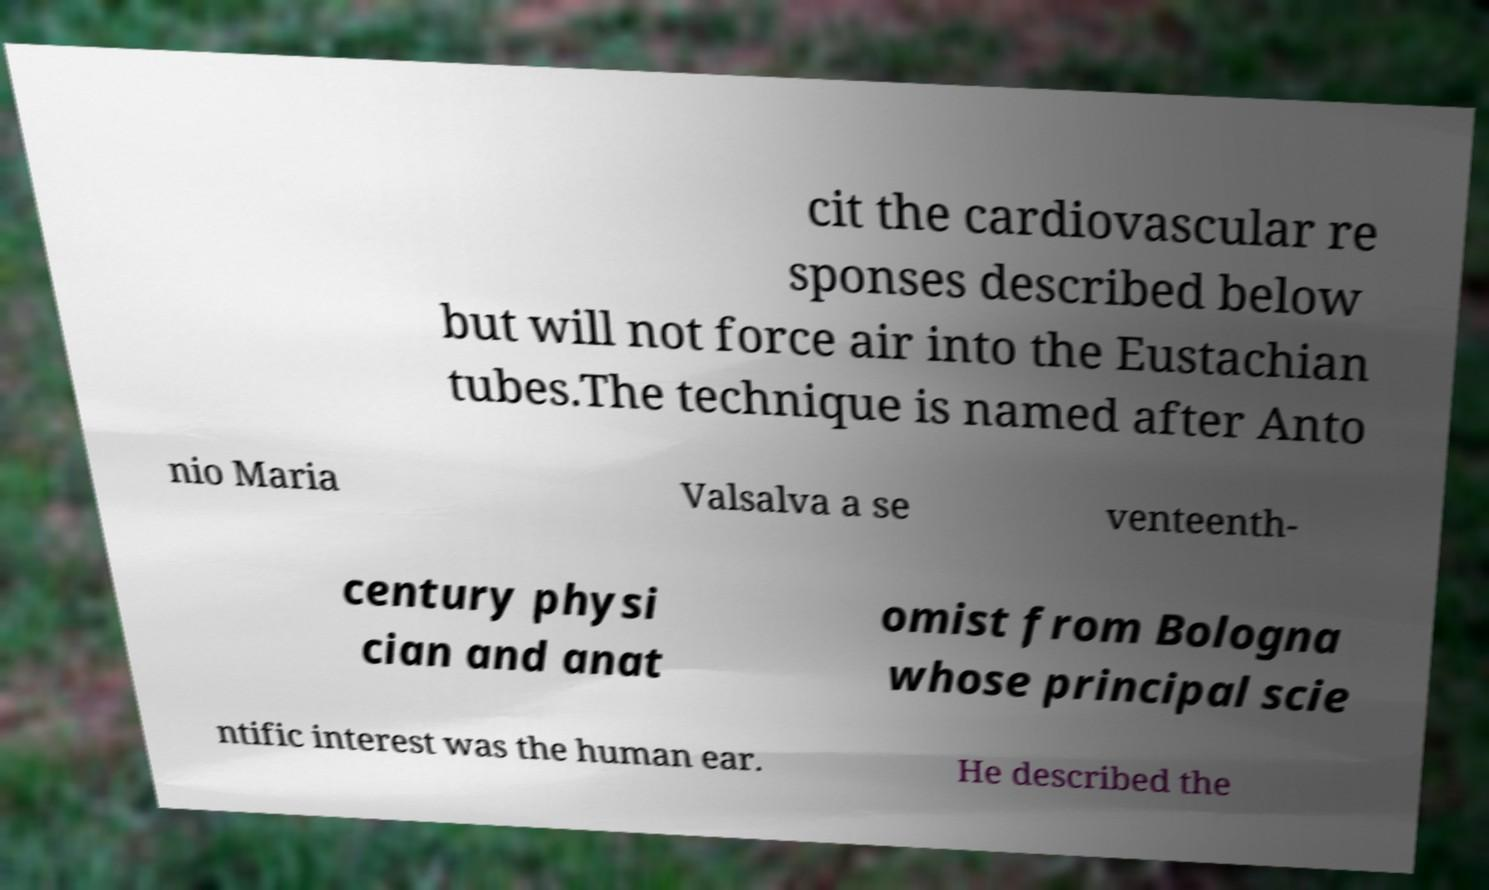Could you extract and type out the text from this image? cit the cardiovascular re sponses described below but will not force air into the Eustachian tubes.The technique is named after Anto nio Maria Valsalva a se venteenth- century physi cian and anat omist from Bologna whose principal scie ntific interest was the human ear. He described the 